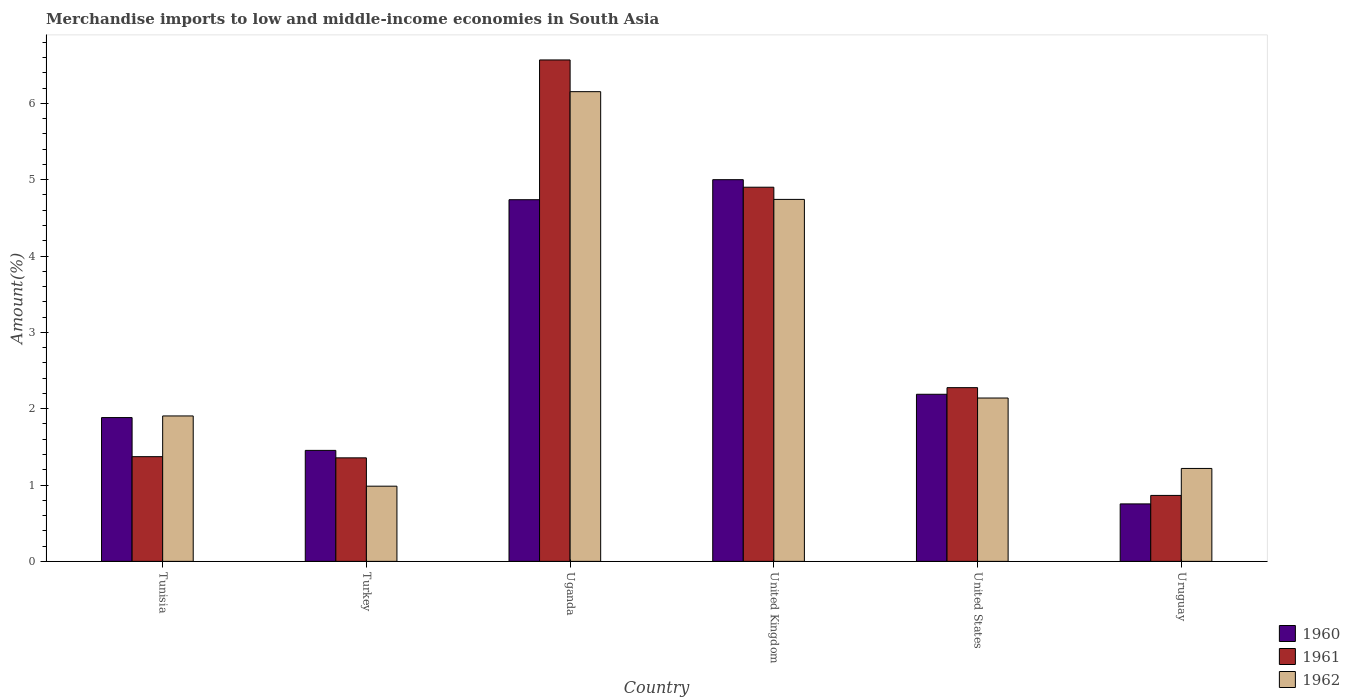How many bars are there on the 3rd tick from the left?
Your answer should be compact. 3. How many bars are there on the 3rd tick from the right?
Your answer should be compact. 3. What is the label of the 4th group of bars from the left?
Provide a short and direct response. United Kingdom. In how many cases, is the number of bars for a given country not equal to the number of legend labels?
Offer a very short reply. 0. What is the percentage of amount earned from merchandise imports in 1960 in Turkey?
Ensure brevity in your answer.  1.45. Across all countries, what is the maximum percentage of amount earned from merchandise imports in 1960?
Your response must be concise. 5. Across all countries, what is the minimum percentage of amount earned from merchandise imports in 1960?
Offer a very short reply. 0.75. In which country was the percentage of amount earned from merchandise imports in 1961 maximum?
Provide a succinct answer. Uganda. In which country was the percentage of amount earned from merchandise imports in 1960 minimum?
Your answer should be compact. Uruguay. What is the total percentage of amount earned from merchandise imports in 1961 in the graph?
Your answer should be very brief. 17.34. What is the difference between the percentage of amount earned from merchandise imports in 1961 in Tunisia and that in United States?
Your response must be concise. -0.9. What is the difference between the percentage of amount earned from merchandise imports in 1961 in Uruguay and the percentage of amount earned from merchandise imports in 1962 in United States?
Your answer should be very brief. -1.28. What is the average percentage of amount earned from merchandise imports in 1962 per country?
Give a very brief answer. 2.86. What is the difference between the percentage of amount earned from merchandise imports of/in 1961 and percentage of amount earned from merchandise imports of/in 1962 in United States?
Provide a short and direct response. 0.14. In how many countries, is the percentage of amount earned from merchandise imports in 1961 greater than 3.4 %?
Make the answer very short. 2. What is the ratio of the percentage of amount earned from merchandise imports in 1961 in Uganda to that in United States?
Your response must be concise. 2.89. Is the percentage of amount earned from merchandise imports in 1962 in Turkey less than that in United Kingdom?
Provide a succinct answer. Yes. What is the difference between the highest and the second highest percentage of amount earned from merchandise imports in 1962?
Your answer should be compact. -2.6. What is the difference between the highest and the lowest percentage of amount earned from merchandise imports in 1962?
Keep it short and to the point. 5.17. How many bars are there?
Provide a succinct answer. 18. Are all the bars in the graph horizontal?
Provide a succinct answer. No. How many countries are there in the graph?
Your answer should be compact. 6. What is the difference between two consecutive major ticks on the Y-axis?
Keep it short and to the point. 1. Does the graph contain any zero values?
Offer a terse response. No. Where does the legend appear in the graph?
Ensure brevity in your answer.  Bottom right. How many legend labels are there?
Your response must be concise. 3. What is the title of the graph?
Your answer should be very brief. Merchandise imports to low and middle-income economies in South Asia. Does "2012" appear as one of the legend labels in the graph?
Ensure brevity in your answer.  No. What is the label or title of the Y-axis?
Give a very brief answer. Amount(%). What is the Amount(%) in 1960 in Tunisia?
Offer a very short reply. 1.88. What is the Amount(%) of 1961 in Tunisia?
Make the answer very short. 1.37. What is the Amount(%) in 1962 in Tunisia?
Give a very brief answer. 1.91. What is the Amount(%) in 1960 in Turkey?
Make the answer very short. 1.45. What is the Amount(%) of 1961 in Turkey?
Offer a terse response. 1.36. What is the Amount(%) of 1962 in Turkey?
Your answer should be very brief. 0.98. What is the Amount(%) of 1960 in Uganda?
Offer a very short reply. 4.74. What is the Amount(%) in 1961 in Uganda?
Your answer should be compact. 6.57. What is the Amount(%) in 1962 in Uganda?
Make the answer very short. 6.15. What is the Amount(%) of 1960 in United Kingdom?
Give a very brief answer. 5. What is the Amount(%) of 1961 in United Kingdom?
Your answer should be very brief. 4.9. What is the Amount(%) in 1962 in United Kingdom?
Your answer should be very brief. 4.74. What is the Amount(%) of 1960 in United States?
Make the answer very short. 2.19. What is the Amount(%) of 1961 in United States?
Provide a short and direct response. 2.28. What is the Amount(%) in 1962 in United States?
Keep it short and to the point. 2.14. What is the Amount(%) of 1960 in Uruguay?
Provide a short and direct response. 0.75. What is the Amount(%) of 1961 in Uruguay?
Give a very brief answer. 0.86. What is the Amount(%) in 1962 in Uruguay?
Provide a short and direct response. 1.22. Across all countries, what is the maximum Amount(%) of 1960?
Your answer should be compact. 5. Across all countries, what is the maximum Amount(%) of 1961?
Make the answer very short. 6.57. Across all countries, what is the maximum Amount(%) in 1962?
Ensure brevity in your answer.  6.15. Across all countries, what is the minimum Amount(%) of 1960?
Offer a terse response. 0.75. Across all countries, what is the minimum Amount(%) of 1961?
Your answer should be very brief. 0.86. Across all countries, what is the minimum Amount(%) of 1962?
Your answer should be very brief. 0.98. What is the total Amount(%) of 1960 in the graph?
Keep it short and to the point. 16.02. What is the total Amount(%) of 1961 in the graph?
Ensure brevity in your answer.  17.34. What is the total Amount(%) of 1962 in the graph?
Ensure brevity in your answer.  17.14. What is the difference between the Amount(%) of 1960 in Tunisia and that in Turkey?
Provide a short and direct response. 0.43. What is the difference between the Amount(%) in 1961 in Tunisia and that in Turkey?
Your answer should be compact. 0.02. What is the difference between the Amount(%) in 1962 in Tunisia and that in Turkey?
Ensure brevity in your answer.  0.92. What is the difference between the Amount(%) of 1960 in Tunisia and that in Uganda?
Offer a very short reply. -2.85. What is the difference between the Amount(%) of 1961 in Tunisia and that in Uganda?
Provide a succinct answer. -5.2. What is the difference between the Amount(%) in 1962 in Tunisia and that in Uganda?
Give a very brief answer. -4.25. What is the difference between the Amount(%) of 1960 in Tunisia and that in United Kingdom?
Keep it short and to the point. -3.12. What is the difference between the Amount(%) of 1961 in Tunisia and that in United Kingdom?
Ensure brevity in your answer.  -3.53. What is the difference between the Amount(%) of 1962 in Tunisia and that in United Kingdom?
Your response must be concise. -2.84. What is the difference between the Amount(%) in 1960 in Tunisia and that in United States?
Provide a short and direct response. -0.31. What is the difference between the Amount(%) of 1961 in Tunisia and that in United States?
Your answer should be compact. -0.9. What is the difference between the Amount(%) in 1962 in Tunisia and that in United States?
Ensure brevity in your answer.  -0.23. What is the difference between the Amount(%) in 1960 in Tunisia and that in Uruguay?
Offer a very short reply. 1.13. What is the difference between the Amount(%) in 1961 in Tunisia and that in Uruguay?
Your response must be concise. 0.51. What is the difference between the Amount(%) in 1962 in Tunisia and that in Uruguay?
Provide a short and direct response. 0.69. What is the difference between the Amount(%) of 1960 in Turkey and that in Uganda?
Offer a very short reply. -3.28. What is the difference between the Amount(%) of 1961 in Turkey and that in Uganda?
Your response must be concise. -5.21. What is the difference between the Amount(%) of 1962 in Turkey and that in Uganda?
Provide a short and direct response. -5.17. What is the difference between the Amount(%) of 1960 in Turkey and that in United Kingdom?
Give a very brief answer. -3.55. What is the difference between the Amount(%) of 1961 in Turkey and that in United Kingdom?
Offer a very short reply. -3.55. What is the difference between the Amount(%) in 1962 in Turkey and that in United Kingdom?
Your answer should be very brief. -3.76. What is the difference between the Amount(%) in 1960 in Turkey and that in United States?
Your answer should be very brief. -0.74. What is the difference between the Amount(%) of 1961 in Turkey and that in United States?
Make the answer very short. -0.92. What is the difference between the Amount(%) of 1962 in Turkey and that in United States?
Provide a succinct answer. -1.16. What is the difference between the Amount(%) in 1960 in Turkey and that in Uruguay?
Provide a short and direct response. 0.7. What is the difference between the Amount(%) of 1961 in Turkey and that in Uruguay?
Keep it short and to the point. 0.49. What is the difference between the Amount(%) of 1962 in Turkey and that in Uruguay?
Keep it short and to the point. -0.23. What is the difference between the Amount(%) of 1960 in Uganda and that in United Kingdom?
Offer a terse response. -0.26. What is the difference between the Amount(%) of 1961 in Uganda and that in United Kingdom?
Ensure brevity in your answer.  1.67. What is the difference between the Amount(%) of 1962 in Uganda and that in United Kingdom?
Provide a short and direct response. 1.41. What is the difference between the Amount(%) in 1960 in Uganda and that in United States?
Make the answer very short. 2.55. What is the difference between the Amount(%) in 1961 in Uganda and that in United States?
Provide a succinct answer. 4.29. What is the difference between the Amount(%) of 1962 in Uganda and that in United States?
Ensure brevity in your answer.  4.01. What is the difference between the Amount(%) of 1960 in Uganda and that in Uruguay?
Make the answer very short. 3.99. What is the difference between the Amount(%) in 1961 in Uganda and that in Uruguay?
Provide a short and direct response. 5.71. What is the difference between the Amount(%) in 1962 in Uganda and that in Uruguay?
Your response must be concise. 4.94. What is the difference between the Amount(%) of 1960 in United Kingdom and that in United States?
Your answer should be compact. 2.81. What is the difference between the Amount(%) of 1961 in United Kingdom and that in United States?
Your answer should be compact. 2.63. What is the difference between the Amount(%) of 1962 in United Kingdom and that in United States?
Provide a succinct answer. 2.6. What is the difference between the Amount(%) of 1960 in United Kingdom and that in Uruguay?
Offer a terse response. 4.25. What is the difference between the Amount(%) in 1961 in United Kingdom and that in Uruguay?
Ensure brevity in your answer.  4.04. What is the difference between the Amount(%) of 1962 in United Kingdom and that in Uruguay?
Keep it short and to the point. 3.52. What is the difference between the Amount(%) in 1960 in United States and that in Uruguay?
Provide a short and direct response. 1.44. What is the difference between the Amount(%) in 1961 in United States and that in Uruguay?
Offer a terse response. 1.41. What is the difference between the Amount(%) in 1962 in United States and that in Uruguay?
Ensure brevity in your answer.  0.92. What is the difference between the Amount(%) in 1960 in Tunisia and the Amount(%) in 1961 in Turkey?
Provide a short and direct response. 0.53. What is the difference between the Amount(%) in 1960 in Tunisia and the Amount(%) in 1962 in Turkey?
Your response must be concise. 0.9. What is the difference between the Amount(%) of 1961 in Tunisia and the Amount(%) of 1962 in Turkey?
Keep it short and to the point. 0.39. What is the difference between the Amount(%) in 1960 in Tunisia and the Amount(%) in 1961 in Uganda?
Offer a terse response. -4.69. What is the difference between the Amount(%) in 1960 in Tunisia and the Amount(%) in 1962 in Uganda?
Your answer should be compact. -4.27. What is the difference between the Amount(%) of 1961 in Tunisia and the Amount(%) of 1962 in Uganda?
Provide a succinct answer. -4.78. What is the difference between the Amount(%) of 1960 in Tunisia and the Amount(%) of 1961 in United Kingdom?
Your answer should be compact. -3.02. What is the difference between the Amount(%) in 1960 in Tunisia and the Amount(%) in 1962 in United Kingdom?
Ensure brevity in your answer.  -2.86. What is the difference between the Amount(%) in 1961 in Tunisia and the Amount(%) in 1962 in United Kingdom?
Keep it short and to the point. -3.37. What is the difference between the Amount(%) in 1960 in Tunisia and the Amount(%) in 1961 in United States?
Ensure brevity in your answer.  -0.39. What is the difference between the Amount(%) of 1960 in Tunisia and the Amount(%) of 1962 in United States?
Provide a succinct answer. -0.26. What is the difference between the Amount(%) in 1961 in Tunisia and the Amount(%) in 1962 in United States?
Your response must be concise. -0.77. What is the difference between the Amount(%) in 1960 in Tunisia and the Amount(%) in 1961 in Uruguay?
Give a very brief answer. 1.02. What is the difference between the Amount(%) of 1960 in Tunisia and the Amount(%) of 1962 in Uruguay?
Give a very brief answer. 0.67. What is the difference between the Amount(%) in 1961 in Tunisia and the Amount(%) in 1962 in Uruguay?
Offer a very short reply. 0.15. What is the difference between the Amount(%) in 1960 in Turkey and the Amount(%) in 1961 in Uganda?
Ensure brevity in your answer.  -5.12. What is the difference between the Amount(%) of 1960 in Turkey and the Amount(%) of 1962 in Uganda?
Give a very brief answer. -4.7. What is the difference between the Amount(%) of 1961 in Turkey and the Amount(%) of 1962 in Uganda?
Offer a very short reply. -4.8. What is the difference between the Amount(%) in 1960 in Turkey and the Amount(%) in 1961 in United Kingdom?
Offer a very short reply. -3.45. What is the difference between the Amount(%) of 1960 in Turkey and the Amount(%) of 1962 in United Kingdom?
Keep it short and to the point. -3.29. What is the difference between the Amount(%) of 1961 in Turkey and the Amount(%) of 1962 in United Kingdom?
Your response must be concise. -3.39. What is the difference between the Amount(%) in 1960 in Turkey and the Amount(%) in 1961 in United States?
Provide a short and direct response. -0.82. What is the difference between the Amount(%) in 1960 in Turkey and the Amount(%) in 1962 in United States?
Keep it short and to the point. -0.69. What is the difference between the Amount(%) in 1961 in Turkey and the Amount(%) in 1962 in United States?
Ensure brevity in your answer.  -0.78. What is the difference between the Amount(%) in 1960 in Turkey and the Amount(%) in 1961 in Uruguay?
Offer a very short reply. 0.59. What is the difference between the Amount(%) in 1960 in Turkey and the Amount(%) in 1962 in Uruguay?
Your answer should be very brief. 0.24. What is the difference between the Amount(%) in 1961 in Turkey and the Amount(%) in 1962 in Uruguay?
Make the answer very short. 0.14. What is the difference between the Amount(%) of 1960 in Uganda and the Amount(%) of 1961 in United Kingdom?
Provide a succinct answer. -0.16. What is the difference between the Amount(%) in 1960 in Uganda and the Amount(%) in 1962 in United Kingdom?
Provide a succinct answer. -0. What is the difference between the Amount(%) of 1961 in Uganda and the Amount(%) of 1962 in United Kingdom?
Your answer should be very brief. 1.83. What is the difference between the Amount(%) of 1960 in Uganda and the Amount(%) of 1961 in United States?
Provide a short and direct response. 2.46. What is the difference between the Amount(%) in 1960 in Uganda and the Amount(%) in 1962 in United States?
Keep it short and to the point. 2.6. What is the difference between the Amount(%) of 1961 in Uganda and the Amount(%) of 1962 in United States?
Your answer should be compact. 4.43. What is the difference between the Amount(%) in 1960 in Uganda and the Amount(%) in 1961 in Uruguay?
Make the answer very short. 3.87. What is the difference between the Amount(%) in 1960 in Uganda and the Amount(%) in 1962 in Uruguay?
Provide a short and direct response. 3.52. What is the difference between the Amount(%) of 1961 in Uganda and the Amount(%) of 1962 in Uruguay?
Provide a short and direct response. 5.35. What is the difference between the Amount(%) of 1960 in United Kingdom and the Amount(%) of 1961 in United States?
Keep it short and to the point. 2.72. What is the difference between the Amount(%) of 1960 in United Kingdom and the Amount(%) of 1962 in United States?
Your response must be concise. 2.86. What is the difference between the Amount(%) of 1961 in United Kingdom and the Amount(%) of 1962 in United States?
Give a very brief answer. 2.76. What is the difference between the Amount(%) of 1960 in United Kingdom and the Amount(%) of 1961 in Uruguay?
Your answer should be very brief. 4.14. What is the difference between the Amount(%) of 1960 in United Kingdom and the Amount(%) of 1962 in Uruguay?
Your answer should be compact. 3.78. What is the difference between the Amount(%) of 1961 in United Kingdom and the Amount(%) of 1962 in Uruguay?
Your answer should be compact. 3.68. What is the difference between the Amount(%) of 1960 in United States and the Amount(%) of 1961 in Uruguay?
Provide a succinct answer. 1.32. What is the difference between the Amount(%) in 1960 in United States and the Amount(%) in 1962 in Uruguay?
Offer a very short reply. 0.97. What is the difference between the Amount(%) of 1961 in United States and the Amount(%) of 1962 in Uruguay?
Provide a short and direct response. 1.06. What is the average Amount(%) in 1960 per country?
Offer a very short reply. 2.67. What is the average Amount(%) in 1961 per country?
Provide a succinct answer. 2.89. What is the average Amount(%) in 1962 per country?
Your answer should be compact. 2.86. What is the difference between the Amount(%) in 1960 and Amount(%) in 1961 in Tunisia?
Make the answer very short. 0.51. What is the difference between the Amount(%) in 1960 and Amount(%) in 1962 in Tunisia?
Offer a very short reply. -0.02. What is the difference between the Amount(%) of 1961 and Amount(%) of 1962 in Tunisia?
Offer a terse response. -0.53. What is the difference between the Amount(%) in 1960 and Amount(%) in 1961 in Turkey?
Provide a short and direct response. 0.1. What is the difference between the Amount(%) in 1960 and Amount(%) in 1962 in Turkey?
Your answer should be compact. 0.47. What is the difference between the Amount(%) in 1961 and Amount(%) in 1962 in Turkey?
Offer a very short reply. 0.37. What is the difference between the Amount(%) of 1960 and Amount(%) of 1961 in Uganda?
Ensure brevity in your answer.  -1.83. What is the difference between the Amount(%) of 1960 and Amount(%) of 1962 in Uganda?
Your answer should be very brief. -1.42. What is the difference between the Amount(%) in 1961 and Amount(%) in 1962 in Uganda?
Offer a terse response. 0.42. What is the difference between the Amount(%) of 1960 and Amount(%) of 1961 in United Kingdom?
Your response must be concise. 0.1. What is the difference between the Amount(%) of 1960 and Amount(%) of 1962 in United Kingdom?
Offer a terse response. 0.26. What is the difference between the Amount(%) of 1961 and Amount(%) of 1962 in United Kingdom?
Your answer should be very brief. 0.16. What is the difference between the Amount(%) of 1960 and Amount(%) of 1961 in United States?
Provide a succinct answer. -0.09. What is the difference between the Amount(%) in 1960 and Amount(%) in 1962 in United States?
Give a very brief answer. 0.05. What is the difference between the Amount(%) of 1961 and Amount(%) of 1962 in United States?
Keep it short and to the point. 0.14. What is the difference between the Amount(%) in 1960 and Amount(%) in 1961 in Uruguay?
Your response must be concise. -0.11. What is the difference between the Amount(%) of 1960 and Amount(%) of 1962 in Uruguay?
Offer a terse response. -0.46. What is the difference between the Amount(%) of 1961 and Amount(%) of 1962 in Uruguay?
Give a very brief answer. -0.35. What is the ratio of the Amount(%) of 1960 in Tunisia to that in Turkey?
Offer a terse response. 1.3. What is the ratio of the Amount(%) of 1961 in Tunisia to that in Turkey?
Keep it short and to the point. 1.01. What is the ratio of the Amount(%) of 1962 in Tunisia to that in Turkey?
Keep it short and to the point. 1.93. What is the ratio of the Amount(%) in 1960 in Tunisia to that in Uganda?
Provide a succinct answer. 0.4. What is the ratio of the Amount(%) of 1961 in Tunisia to that in Uganda?
Offer a very short reply. 0.21. What is the ratio of the Amount(%) in 1962 in Tunisia to that in Uganda?
Your answer should be compact. 0.31. What is the ratio of the Amount(%) in 1960 in Tunisia to that in United Kingdom?
Provide a succinct answer. 0.38. What is the ratio of the Amount(%) in 1961 in Tunisia to that in United Kingdom?
Provide a short and direct response. 0.28. What is the ratio of the Amount(%) of 1962 in Tunisia to that in United Kingdom?
Keep it short and to the point. 0.4. What is the ratio of the Amount(%) of 1960 in Tunisia to that in United States?
Your response must be concise. 0.86. What is the ratio of the Amount(%) of 1961 in Tunisia to that in United States?
Ensure brevity in your answer.  0.6. What is the ratio of the Amount(%) in 1962 in Tunisia to that in United States?
Keep it short and to the point. 0.89. What is the ratio of the Amount(%) of 1960 in Tunisia to that in Uruguay?
Ensure brevity in your answer.  2.5. What is the ratio of the Amount(%) in 1961 in Tunisia to that in Uruguay?
Provide a short and direct response. 1.59. What is the ratio of the Amount(%) in 1962 in Tunisia to that in Uruguay?
Your answer should be very brief. 1.56. What is the ratio of the Amount(%) in 1960 in Turkey to that in Uganda?
Your answer should be very brief. 0.31. What is the ratio of the Amount(%) of 1961 in Turkey to that in Uganda?
Provide a succinct answer. 0.21. What is the ratio of the Amount(%) of 1962 in Turkey to that in Uganda?
Provide a short and direct response. 0.16. What is the ratio of the Amount(%) of 1960 in Turkey to that in United Kingdom?
Your answer should be very brief. 0.29. What is the ratio of the Amount(%) in 1961 in Turkey to that in United Kingdom?
Provide a succinct answer. 0.28. What is the ratio of the Amount(%) of 1962 in Turkey to that in United Kingdom?
Provide a short and direct response. 0.21. What is the ratio of the Amount(%) of 1960 in Turkey to that in United States?
Provide a succinct answer. 0.66. What is the ratio of the Amount(%) in 1961 in Turkey to that in United States?
Ensure brevity in your answer.  0.6. What is the ratio of the Amount(%) of 1962 in Turkey to that in United States?
Offer a terse response. 0.46. What is the ratio of the Amount(%) in 1960 in Turkey to that in Uruguay?
Your response must be concise. 1.93. What is the ratio of the Amount(%) in 1961 in Turkey to that in Uruguay?
Ensure brevity in your answer.  1.57. What is the ratio of the Amount(%) of 1962 in Turkey to that in Uruguay?
Keep it short and to the point. 0.81. What is the ratio of the Amount(%) of 1960 in Uganda to that in United Kingdom?
Your answer should be compact. 0.95. What is the ratio of the Amount(%) of 1961 in Uganda to that in United Kingdom?
Make the answer very short. 1.34. What is the ratio of the Amount(%) in 1962 in Uganda to that in United Kingdom?
Your answer should be compact. 1.3. What is the ratio of the Amount(%) of 1960 in Uganda to that in United States?
Offer a very short reply. 2.16. What is the ratio of the Amount(%) in 1961 in Uganda to that in United States?
Offer a terse response. 2.89. What is the ratio of the Amount(%) of 1962 in Uganda to that in United States?
Offer a very short reply. 2.88. What is the ratio of the Amount(%) in 1960 in Uganda to that in Uruguay?
Give a very brief answer. 6.29. What is the ratio of the Amount(%) of 1961 in Uganda to that in Uruguay?
Offer a very short reply. 7.6. What is the ratio of the Amount(%) in 1962 in Uganda to that in Uruguay?
Make the answer very short. 5.05. What is the ratio of the Amount(%) of 1960 in United Kingdom to that in United States?
Ensure brevity in your answer.  2.28. What is the ratio of the Amount(%) in 1961 in United Kingdom to that in United States?
Offer a very short reply. 2.15. What is the ratio of the Amount(%) of 1962 in United Kingdom to that in United States?
Your answer should be compact. 2.22. What is the ratio of the Amount(%) in 1960 in United Kingdom to that in Uruguay?
Offer a very short reply. 6.64. What is the ratio of the Amount(%) in 1961 in United Kingdom to that in Uruguay?
Offer a terse response. 5.67. What is the ratio of the Amount(%) of 1962 in United Kingdom to that in Uruguay?
Offer a very short reply. 3.9. What is the ratio of the Amount(%) of 1960 in United States to that in Uruguay?
Your answer should be very brief. 2.91. What is the ratio of the Amount(%) in 1961 in United States to that in Uruguay?
Offer a very short reply. 2.63. What is the ratio of the Amount(%) in 1962 in United States to that in Uruguay?
Provide a succinct answer. 1.76. What is the difference between the highest and the second highest Amount(%) in 1960?
Your response must be concise. 0.26. What is the difference between the highest and the second highest Amount(%) in 1961?
Your answer should be very brief. 1.67. What is the difference between the highest and the second highest Amount(%) in 1962?
Make the answer very short. 1.41. What is the difference between the highest and the lowest Amount(%) of 1960?
Give a very brief answer. 4.25. What is the difference between the highest and the lowest Amount(%) of 1961?
Your response must be concise. 5.71. What is the difference between the highest and the lowest Amount(%) in 1962?
Make the answer very short. 5.17. 